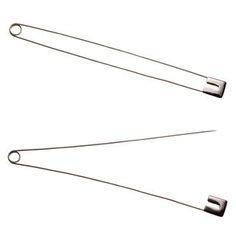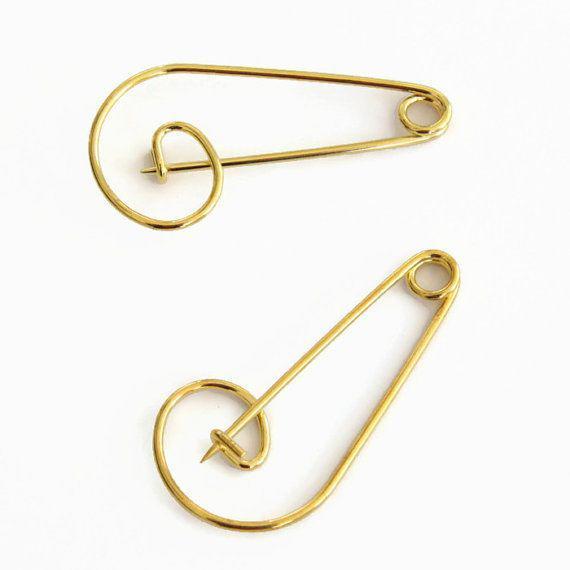The first image is the image on the left, the second image is the image on the right. Given the left and right images, does the statement "There are more pins in the image on the right." hold true? Answer yes or no. No. The first image is the image on the left, the second image is the image on the right. Analyze the images presented: Is the assertion "An image shows overlapping safety pins." valid? Answer yes or no. No. 